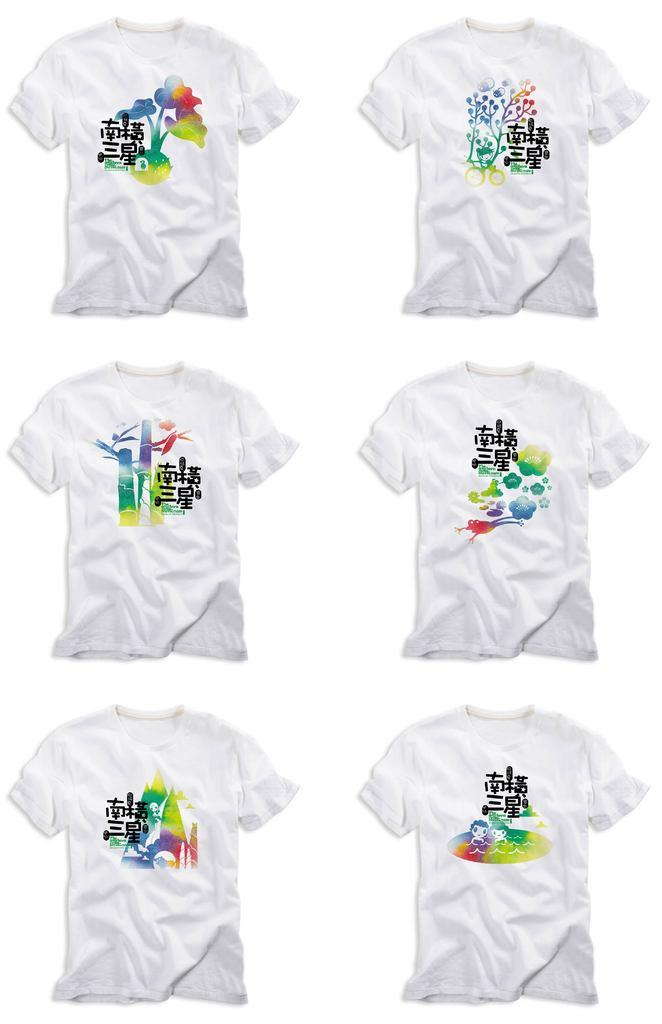What type of clothing is featured in the image? There are printed T-shirts in the image. What color is the background of the image? The background of the image is white. Are there any cobwebs visible in the image? There are no cobwebs present in the image. How many pigs can be seen wearing the printed T-shirts in the image? There are no pigs present in the image, and therefore no pigs wearing the T-shirts. 